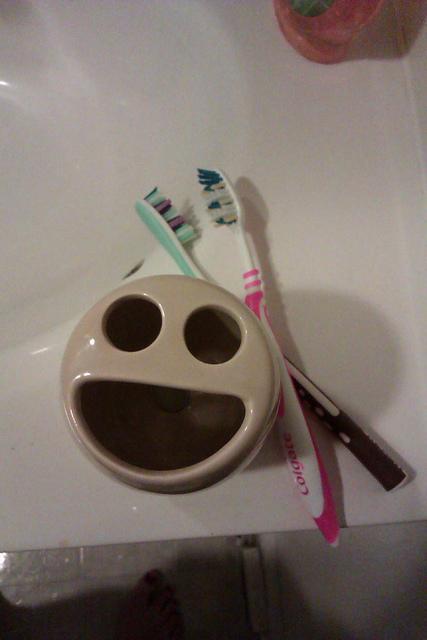What is the purpose of the cup?

Choices:
A) carry drinks
B) is novelty
C) carry toothbrushes
D) child's drink is novelty 